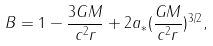<formula> <loc_0><loc_0><loc_500><loc_500>B = 1 - \frac { 3 G M } { c ^ { 2 } r } + 2 a _ { \ast } ( \frac { G M } { c ^ { 2 } r } ) ^ { 3 / 2 } ,</formula> 